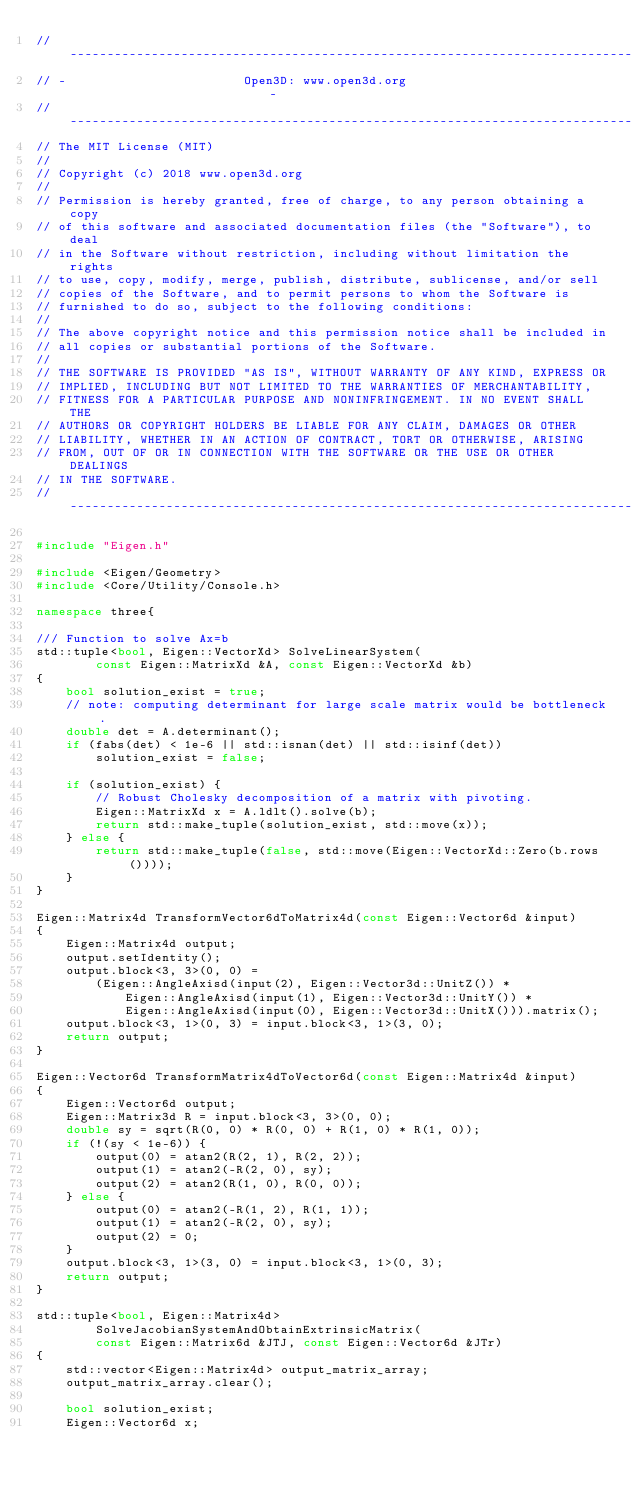Convert code to text. <code><loc_0><loc_0><loc_500><loc_500><_C++_>// ----------------------------------------------------------------------------
// -                        Open3D: www.open3d.org                            -
// ----------------------------------------------------------------------------
// The MIT License (MIT)
//
// Copyright (c) 2018 www.open3d.org
//
// Permission is hereby granted, free of charge, to any person obtaining a copy
// of this software and associated documentation files (the "Software"), to deal
// in the Software without restriction, including without limitation the rights
// to use, copy, modify, merge, publish, distribute, sublicense, and/or sell
// copies of the Software, and to permit persons to whom the Software is
// furnished to do so, subject to the following conditions:
//
// The above copyright notice and this permission notice shall be included in
// all copies or substantial portions of the Software.
//
// THE SOFTWARE IS PROVIDED "AS IS", WITHOUT WARRANTY OF ANY KIND, EXPRESS OR
// IMPLIED, INCLUDING BUT NOT LIMITED TO THE WARRANTIES OF MERCHANTABILITY,
// FITNESS FOR A PARTICULAR PURPOSE AND NONINFRINGEMENT. IN NO EVENT SHALL THE
// AUTHORS OR COPYRIGHT HOLDERS BE LIABLE FOR ANY CLAIM, DAMAGES OR OTHER
// LIABILITY, WHETHER IN AN ACTION OF CONTRACT, TORT OR OTHERWISE, ARISING
// FROM, OUT OF OR IN CONNECTION WITH THE SOFTWARE OR THE USE OR OTHER DEALINGS
// IN THE SOFTWARE.
// ----------------------------------------------------------------------------

#include "Eigen.h"

#include <Eigen/Geometry>
#include <Core/Utility/Console.h>

namespace three{

/// Function to solve Ax=b
std::tuple<bool, Eigen::VectorXd> SolveLinearSystem(
        const Eigen::MatrixXd &A, const Eigen::VectorXd &b)
{
    bool solution_exist = true;
    // note: computing determinant for large scale matrix would be bottleneck.
    double det = A.determinant();
    if (fabs(det) < 1e-6 || std::isnan(det) || std::isinf(det))
        solution_exist = false;

    if (solution_exist) {
        // Robust Cholesky decomposition of a matrix with pivoting.
        Eigen::MatrixXd x = A.ldlt().solve(b);
        return std::make_tuple(solution_exist, std::move(x));
    } else {
        return std::make_tuple(false, std::move(Eigen::VectorXd::Zero(b.rows())));
    }
}

Eigen::Matrix4d TransformVector6dToMatrix4d(const Eigen::Vector6d &input)
{
    Eigen::Matrix4d output;
    output.setIdentity();
    output.block<3, 3>(0, 0) =
        (Eigen::AngleAxisd(input(2), Eigen::Vector3d::UnitZ()) *
            Eigen::AngleAxisd(input(1), Eigen::Vector3d::UnitY()) *
            Eigen::AngleAxisd(input(0), Eigen::Vector3d::UnitX())).matrix();
    output.block<3, 1>(0, 3) = input.block<3, 1>(3, 0);
    return output;
}

Eigen::Vector6d TransformMatrix4dToVector6d(const Eigen::Matrix4d &input)
{
    Eigen::Vector6d output;
    Eigen::Matrix3d R = input.block<3, 3>(0, 0);
    double sy = sqrt(R(0, 0) * R(0, 0) + R(1, 0) * R(1, 0));
    if (!(sy < 1e-6)) {
        output(0) = atan2(R(2, 1), R(2, 2));
        output(1) = atan2(-R(2, 0), sy);
        output(2) = atan2(R(1, 0), R(0, 0));
    } else {
        output(0) = atan2(-R(1, 2), R(1, 1));
        output(1) = atan2(-R(2, 0), sy);
        output(2) = 0;
    }
    output.block<3, 1>(3, 0) = input.block<3, 1>(0, 3);
    return output;
}

std::tuple<bool, Eigen::Matrix4d>
        SolveJacobianSystemAndObtainExtrinsicMatrix(
        const Eigen::Matrix6d &JTJ, const Eigen::Vector6d &JTr)
{
    std::vector<Eigen::Matrix4d> output_matrix_array;
    output_matrix_array.clear();

    bool solution_exist;
    Eigen::Vector6d x;</code> 